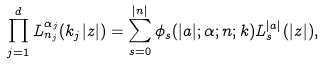Convert formula to latex. <formula><loc_0><loc_0><loc_500><loc_500>\prod _ { j = 1 } ^ { d } L _ { n _ { j } } ^ { \alpha _ { j } } ( k _ { j } | z | ) = \sum _ { s = 0 } ^ { | n | } \phi _ { s } ( | a | ; \alpha ; n ; k ) L _ { s } ^ { | a | } ( | z | ) ,</formula> 